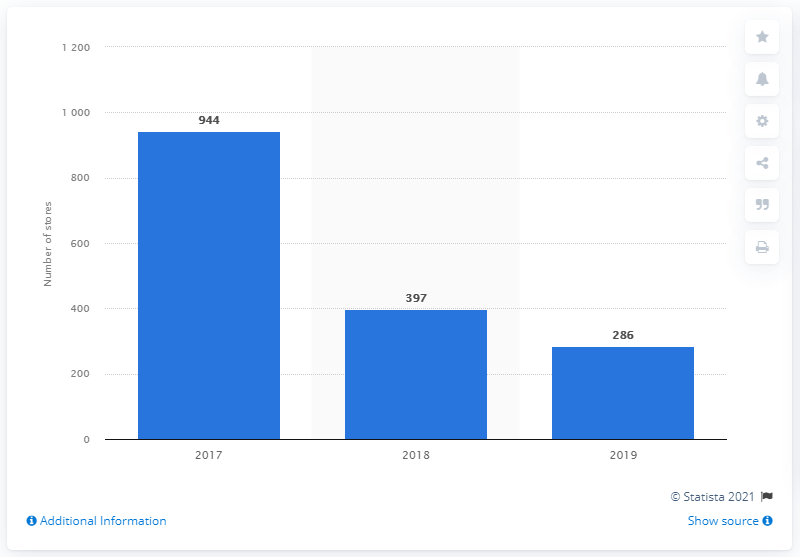Give some essential details in this illustration. Sears operated 286 stores in the United States in 2019. 